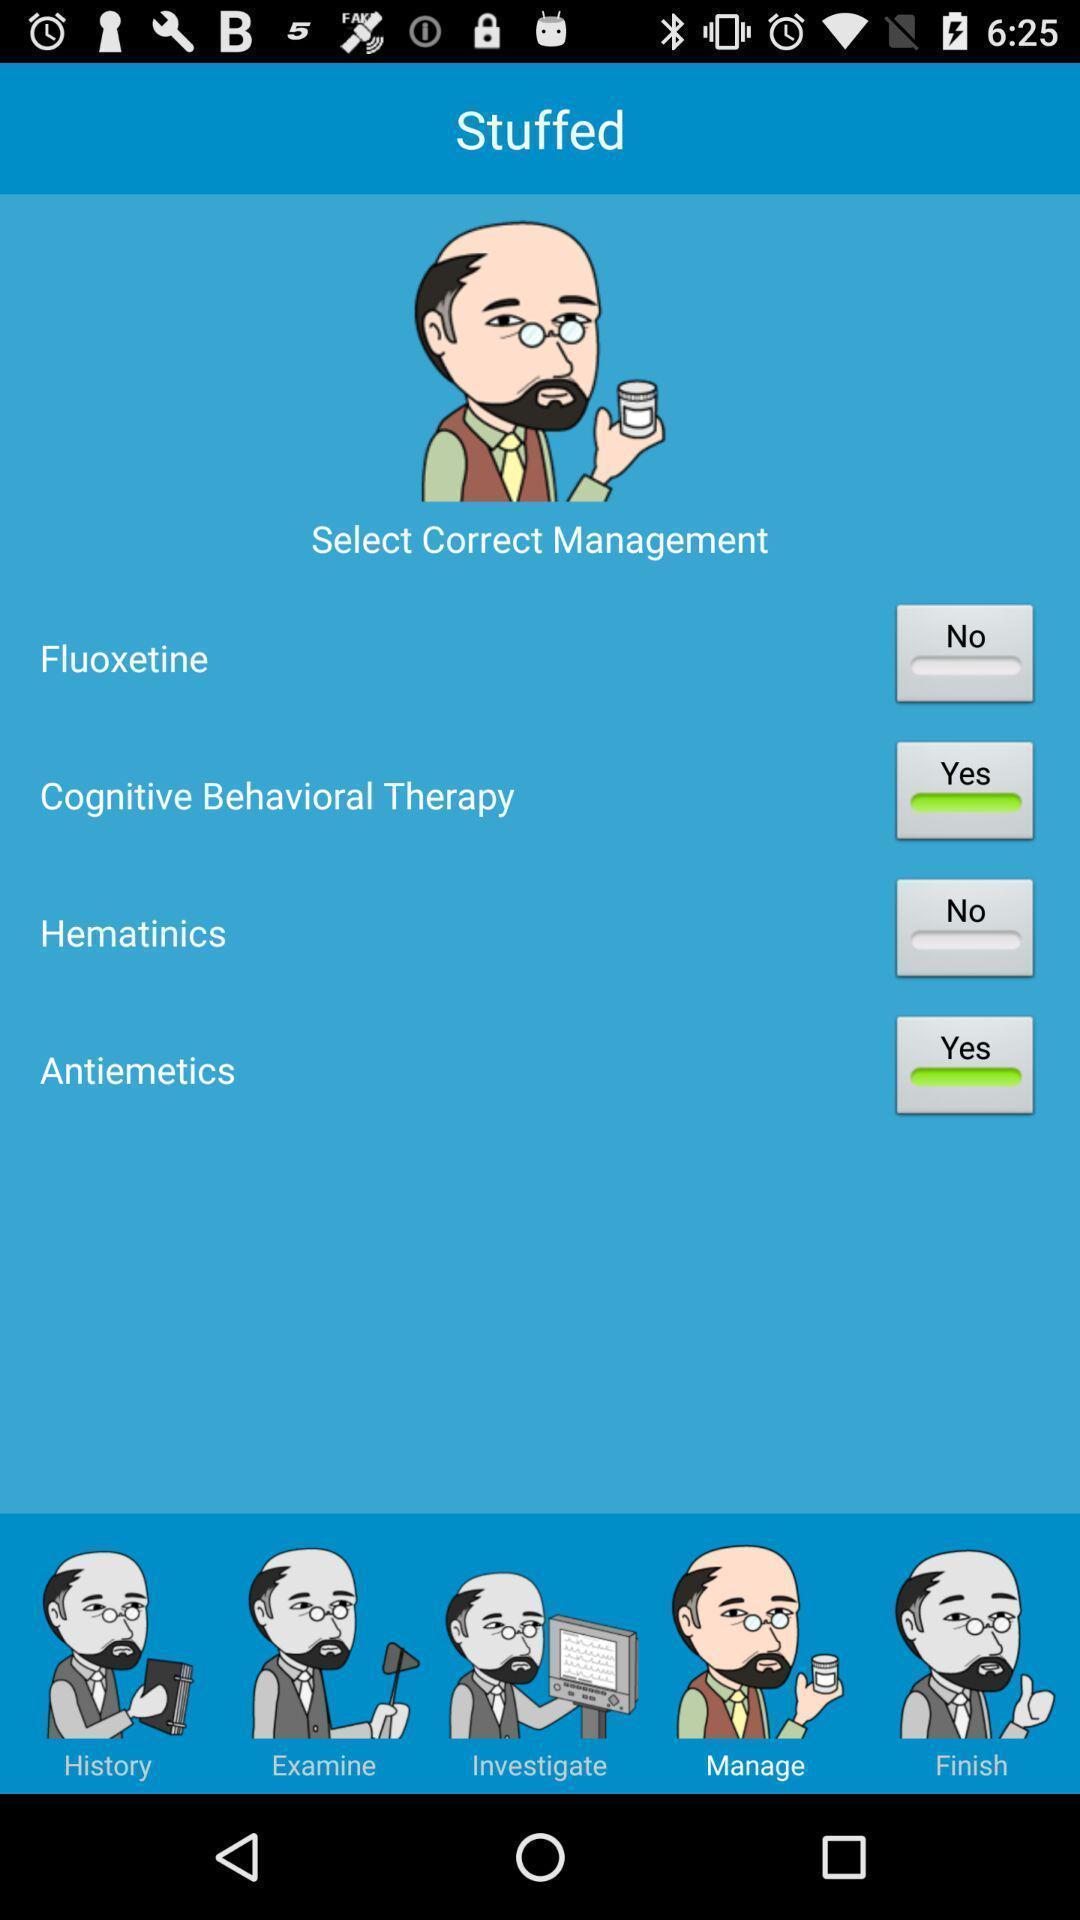What can you discern from this picture? Screen displaying screen page. 